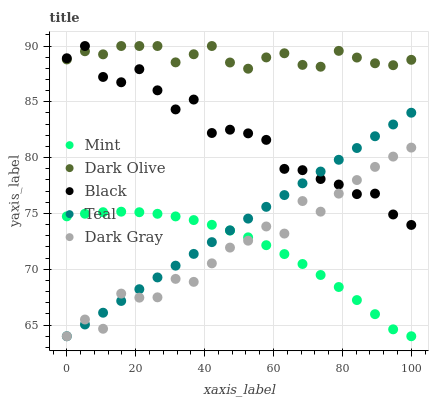Does Mint have the minimum area under the curve?
Answer yes or no. Yes. Does Dark Olive have the maximum area under the curve?
Answer yes or no. Yes. Does Black have the minimum area under the curve?
Answer yes or no. No. Does Black have the maximum area under the curve?
Answer yes or no. No. Is Teal the smoothest?
Answer yes or no. Yes. Is Black the roughest?
Answer yes or no. Yes. Is Dark Olive the smoothest?
Answer yes or no. No. Is Dark Olive the roughest?
Answer yes or no. No. Does Dark Gray have the lowest value?
Answer yes or no. Yes. Does Black have the lowest value?
Answer yes or no. No. Does Dark Olive have the highest value?
Answer yes or no. Yes. Does Mint have the highest value?
Answer yes or no. No. Is Dark Gray less than Dark Olive?
Answer yes or no. Yes. Is Dark Olive greater than Mint?
Answer yes or no. Yes. Does Black intersect Teal?
Answer yes or no. Yes. Is Black less than Teal?
Answer yes or no. No. Is Black greater than Teal?
Answer yes or no. No. Does Dark Gray intersect Dark Olive?
Answer yes or no. No. 